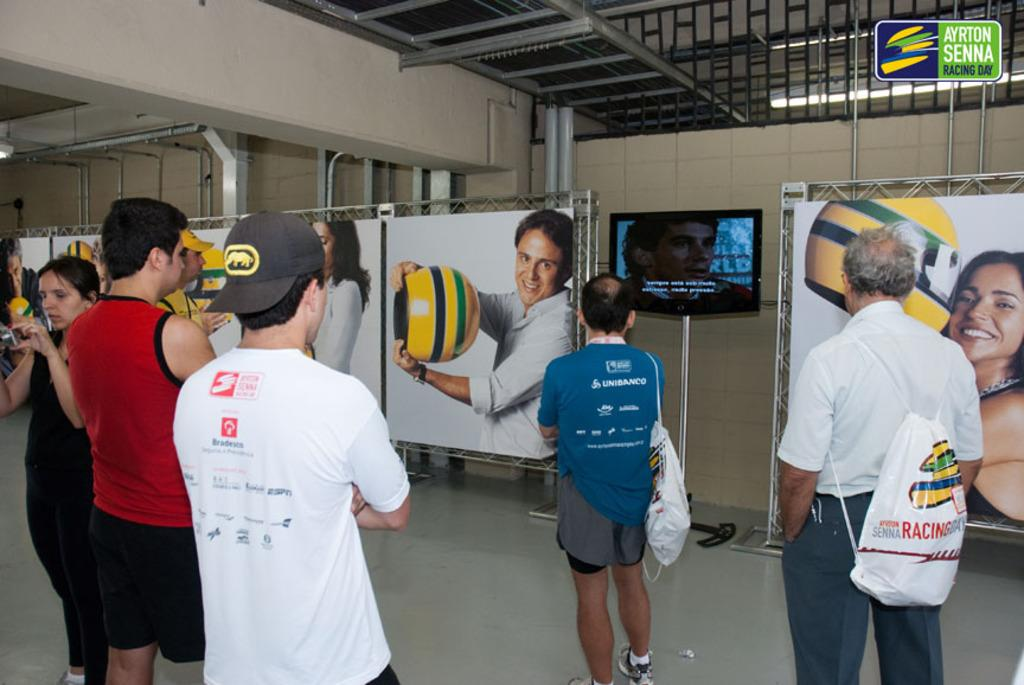What is the main subject of the image? The main subject of the image is a group of men. Where are the men positioned in the image? The men are standing in the front. What are the men doing in the image? The men are watching a television. What can be seen on the walls in the image? There are white posters visible in the image. What is visible at the top of the image? There are grills visible at the top of the image. Can you tell me how many sheep are present in the image? There are no sheep present in the image; it features a group of men watching a television. What type of mice can be seen interacting with the grills in the image? There are no mice present in the image; only the grills are visible at the top. 